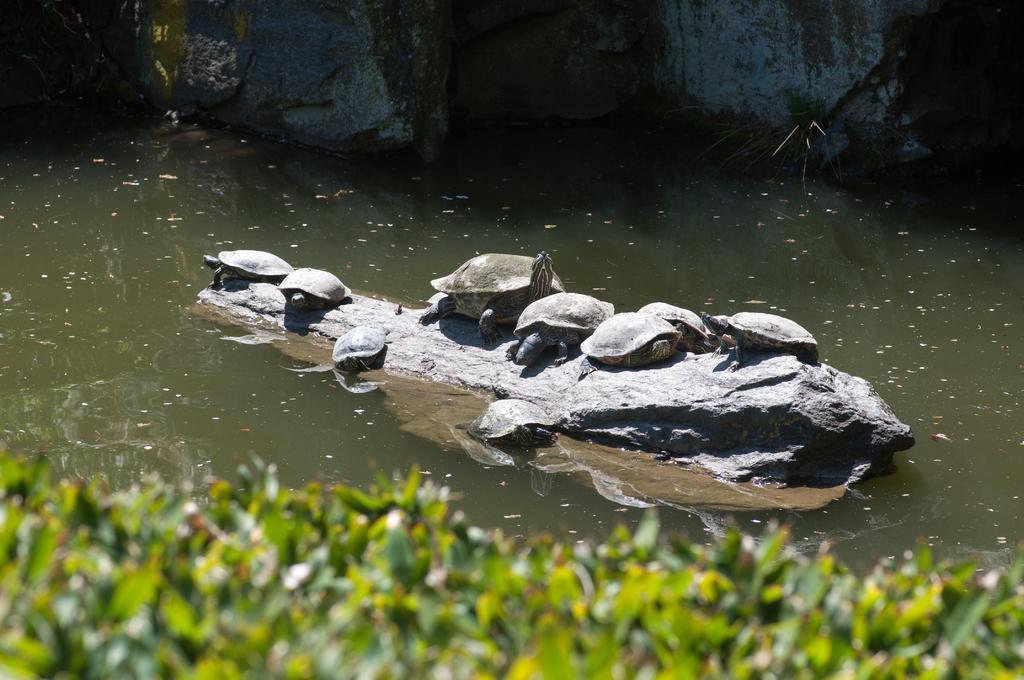Can you describe this image briefly? Here in this, in the middle we can see a rock stone present in the water and on that we can see number of tortoises present and we can also see some plants present in water and in the front we can seagrass present on the ground in blurry manner. 